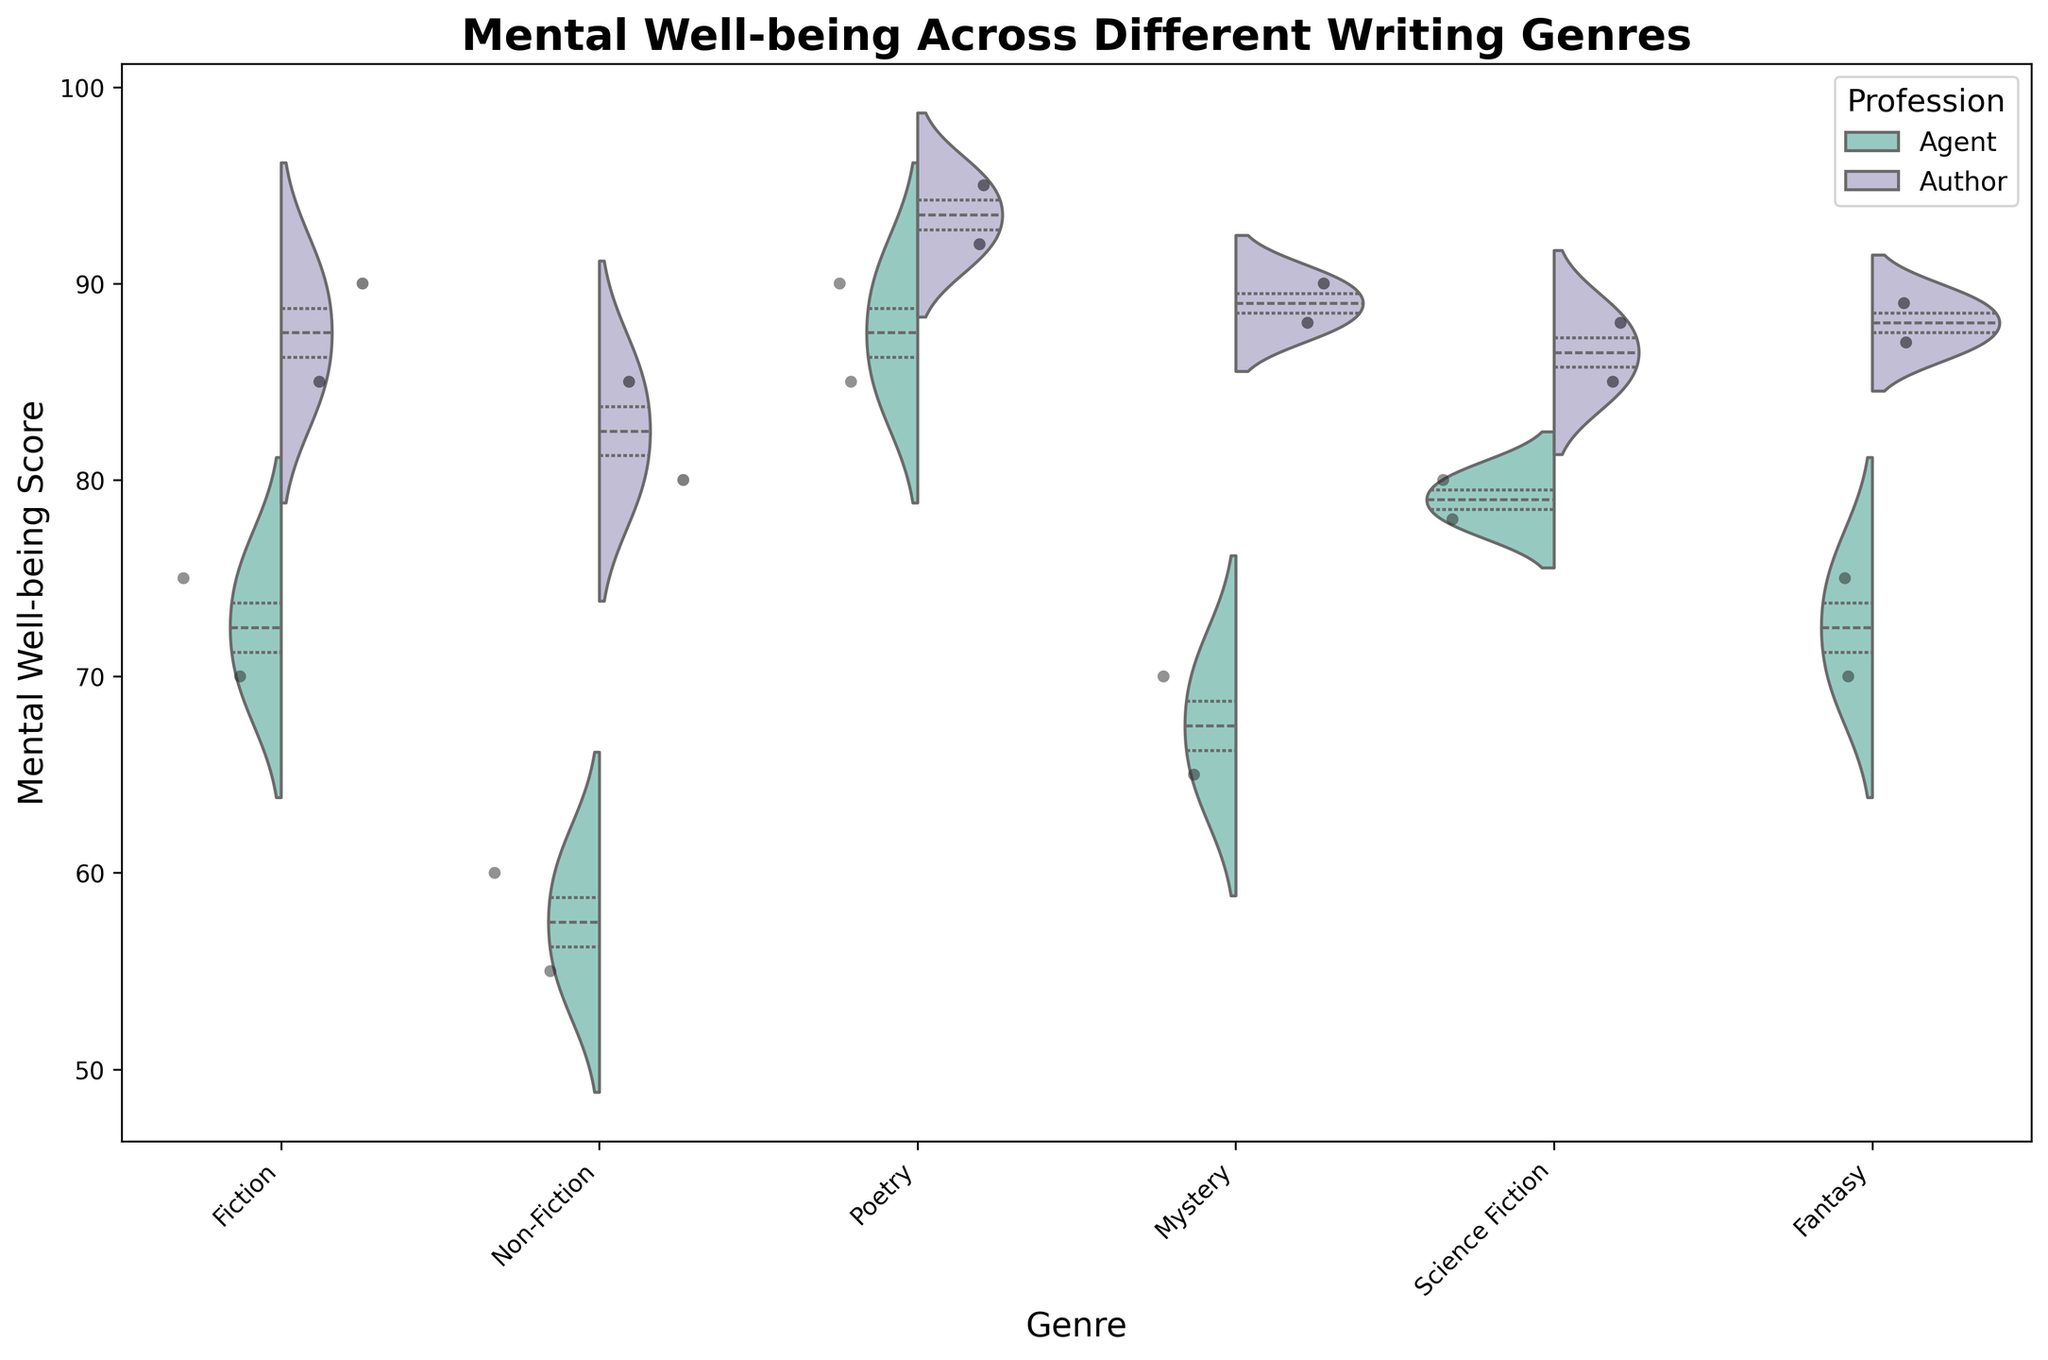What is the title of the plot? The title is displayed at the top of the chart in bold font.
Answer: Mental Well-being Across Different Writing Genres Which genre shows the highest median mental well-being score for Authors? By observing the quartiles inside the violin plots, the genre with the highest median value for Authors is Poetry.
Answer: Poetry How do the median mental well-being scores compare between Agents and Authors in Fiction? The median scores are indicated by the white dots in the violins. In Fiction, the median for Authors is higher than that for Agents.
Answer: Authors have a higher median What is the overall trend in mental well-being scores across genres for Authors? Most mental well-being scores for Authors are clustered above 85 for all genres, indicating generally high well-being.
Answer: Generally high well-being Which genre displays the widest range of mental well-being scores for Agents? By looking at the spread of the violin plots, Non-Fiction displays the widest range for Agents.
Answer: Non-Fiction For which profession does Poetry show a greater range of scores compared to Fiction? Comparing the spans of the violin plots, Poetry shows a greater range of scores for both Agents and Authors compared to Fiction.
Answer: Both What is the range of mental well-being scores for Agents in Mystery? The range is the span from the lowest to the highest point of the violin plot for Agents in Mystery, which goes from 65 to 70.
Answer: 65 to 70 Which profession shows more variability in their mental well-being scores across all genres combined? By evaluating the spread and tightness of the violin plots, Agents exhibit more variability in their scores across genres.
Answer: Agents What is the average mental well-being score for Authors in Science Fiction? The two individual scores for Authors in Science Fiction are 85 and 88. Adding these gives 173, and dividing by 2 gives the average, which is 86.5.
Answer: 86.5 Which profession has higher overall scores in Fantasy? By comparing the violins, the Authors generally score higher than the Agents in Fantasy.
Answer: Authors 